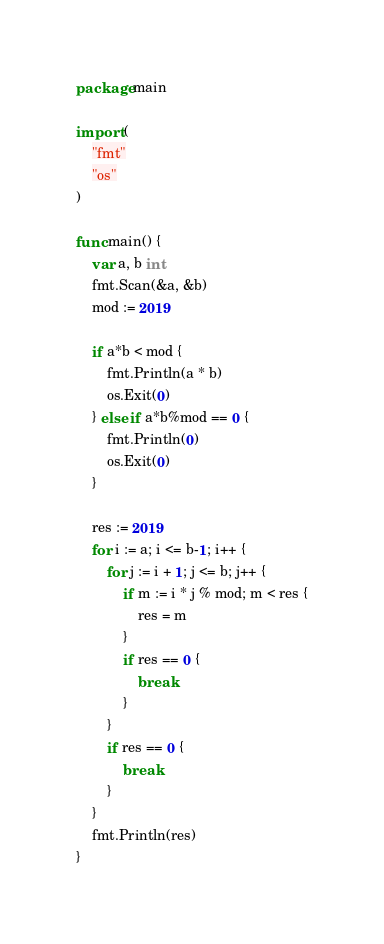<code> <loc_0><loc_0><loc_500><loc_500><_Go_>package main

import (
	"fmt"
	"os"
)

func main() {
	var a, b int
	fmt.Scan(&a, &b)
	mod := 2019

	if a*b < mod {
		fmt.Println(a * b)
		os.Exit(0)
	} else if a*b%mod == 0 {
		fmt.Println(0)
		os.Exit(0)
	}

	res := 2019
	for i := a; i <= b-1; i++ {
		for j := i + 1; j <= b; j++ {
			if m := i * j % mod; m < res {
				res = m
			}
			if res == 0 {
				break
			}
		}
		if res == 0 {
			break
		}
	}
	fmt.Println(res)
}
</code> 